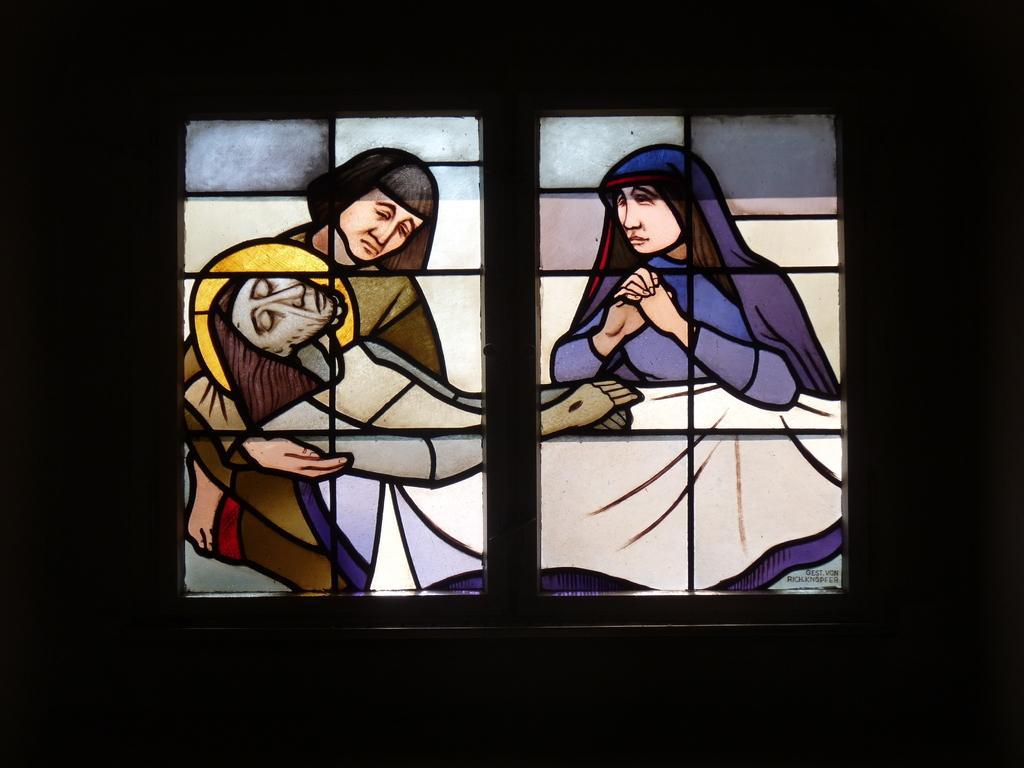How would you summarize this image in a sentence or two? In this picture we can see the glass window with crafted sketch painting on the glass. In the front we can see two women and a man lying on the hand. 